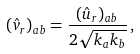Convert formula to latex. <formula><loc_0><loc_0><loc_500><loc_500>( \hat { v } _ { r } ) _ { a b } = \frac { ( \hat { u } _ { r } ) _ { a b } } { 2 \sqrt { k _ { a } k _ { b } } } \, ,</formula> 